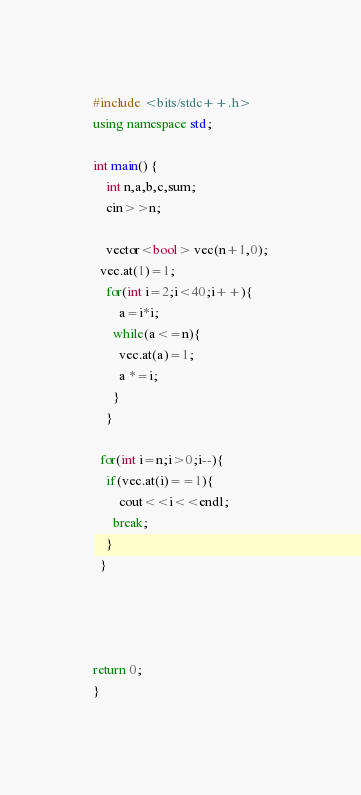Convert code to text. <code><loc_0><loc_0><loc_500><loc_500><_C++_>#include <bits/stdc++.h>
using namespace std;

int main() {
	int n,a,b,c,sum;
  	cin>>n;

	vector<bool> vec(n+1,0);
  vec.at(1)=1;
  	for(int i=2;i<40;i++){
    	a=i*i;
      while(a<=n){
      	vec.at(a)=1;
        a *=i;
      }
    }
  
  for(int i=n;i>0;i--){
  	if(vec.at(i)==1){
    	cout<<i<<endl;
      break;
    }
  }
  
  	
  
  
return 0;
}</code> 